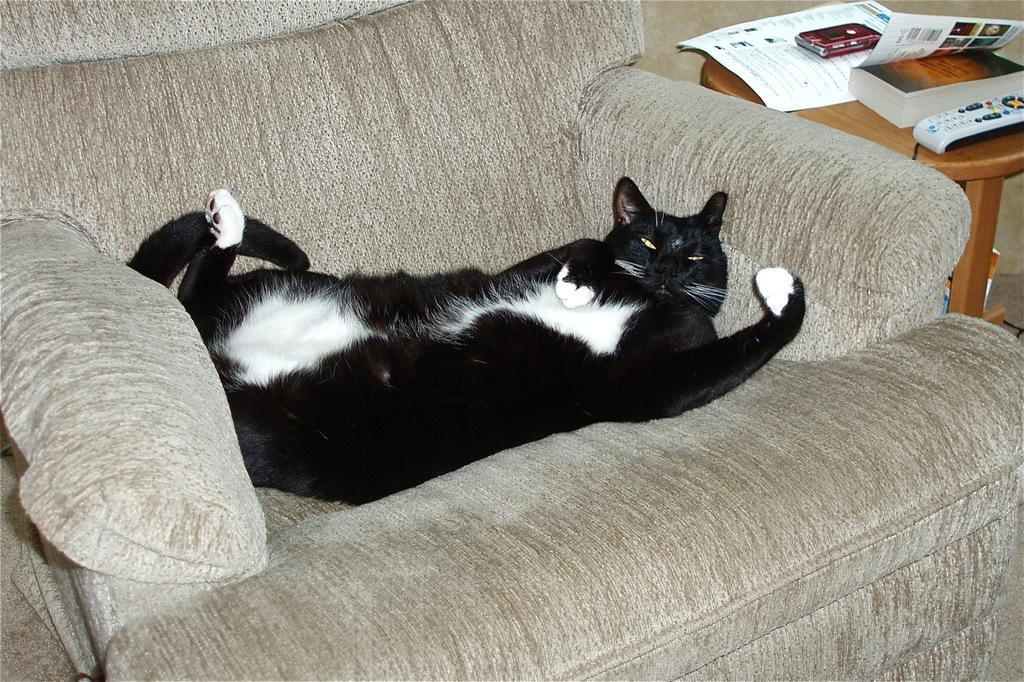What piece of furniture is in the image? There is a couch in the image. What is on the couch? A cat is lying on the couch. What is on the right side of the couch? There is a table on the right side of the couch. What items are on the table? There is a remote, a book, a wallet, and a paper on the table. What type of lunch is the cat eating on the couch? There is no lunch present in the image; the cat is simply lying on the couch. 